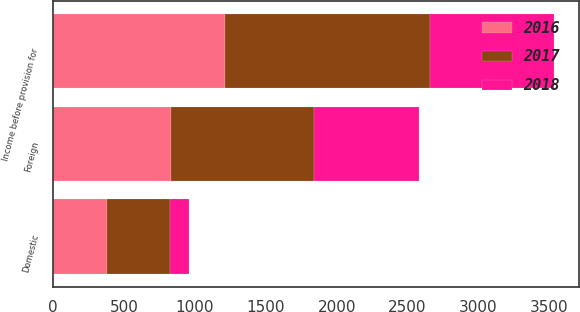Convert chart. <chart><loc_0><loc_0><loc_500><loc_500><stacked_bar_chart><ecel><fcel>Domestic<fcel>Foreign<fcel>Income before provision for<nl><fcel>2017<fcel>440<fcel>1009<fcel>1449<nl><fcel>2016<fcel>382<fcel>828<fcel>1210<nl><fcel>2018<fcel>133<fcel>744<fcel>877<nl></chart> 